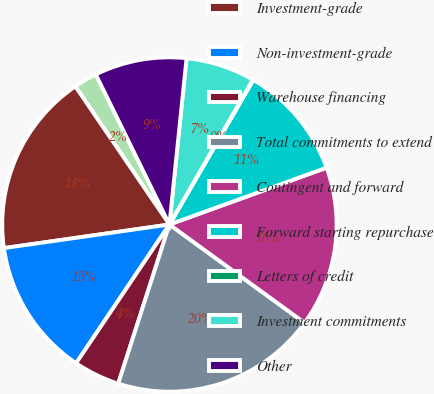Convert chart. <chart><loc_0><loc_0><loc_500><loc_500><pie_chart><fcel>in millions<fcel>Investment-grade<fcel>Non-investment-grade<fcel>Warehouse financing<fcel>Total commitments to extend<fcel>Contingent and forward<fcel>Forward starting repurchase<fcel>Letters of credit<fcel>Investment commitments<fcel>Other<nl><fcel>2.26%<fcel>17.74%<fcel>13.32%<fcel>4.47%<fcel>19.95%<fcel>15.53%<fcel>11.11%<fcel>0.05%<fcel>6.68%<fcel>8.89%<nl></chart> 